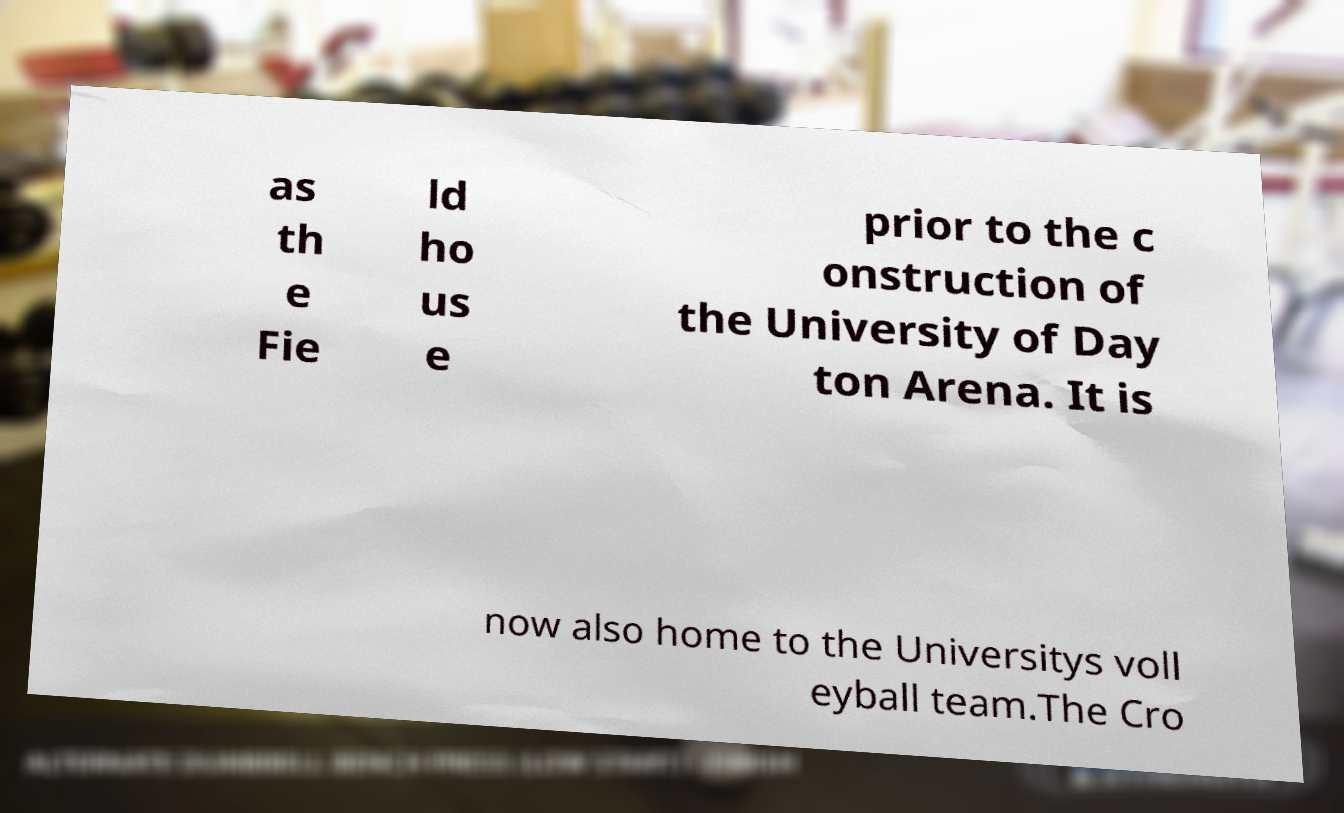Please identify and transcribe the text found in this image. as th e Fie ld ho us e prior to the c onstruction of the University of Day ton Arena. It is now also home to the Universitys voll eyball team.The Cro 